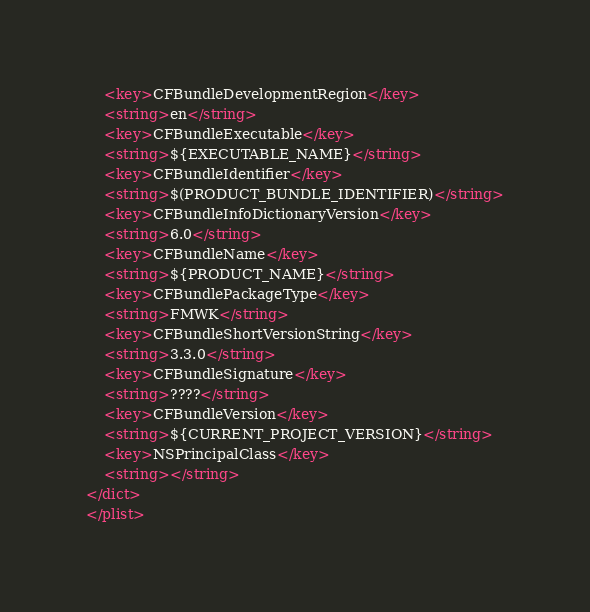Convert code to text. <code><loc_0><loc_0><loc_500><loc_500><_XML_>	<key>CFBundleDevelopmentRegion</key>
	<string>en</string>
	<key>CFBundleExecutable</key>
	<string>${EXECUTABLE_NAME}</string>
	<key>CFBundleIdentifier</key>
	<string>$(PRODUCT_BUNDLE_IDENTIFIER)</string>
	<key>CFBundleInfoDictionaryVersion</key>
	<string>6.0</string>
	<key>CFBundleName</key>
	<string>${PRODUCT_NAME}</string>
	<key>CFBundlePackageType</key>
	<string>FMWK</string>
	<key>CFBundleShortVersionString</key>
	<string>3.3.0</string>
	<key>CFBundleSignature</key>
	<string>????</string>
	<key>CFBundleVersion</key>
	<string>${CURRENT_PROJECT_VERSION}</string>
	<key>NSPrincipalClass</key>
	<string></string>
</dict>
</plist>
</code> 